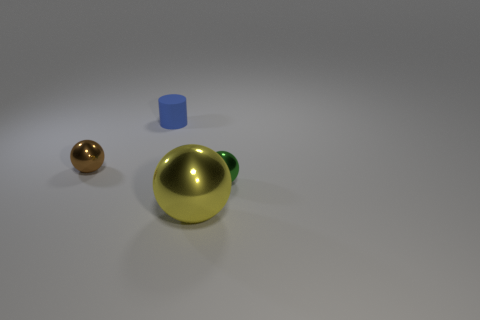Is there anything else that is the same material as the tiny blue cylinder?
Your answer should be very brief. No. What number of other objects are there of the same size as the blue cylinder?
Provide a succinct answer. 2. Does the tiny shiny thing in front of the brown thing have the same shape as the yellow thing?
Ensure brevity in your answer.  Yes. What number of small things are right of the brown shiny object and in front of the blue rubber cylinder?
Your answer should be very brief. 1. What is the blue cylinder made of?
Keep it short and to the point. Rubber. Does the big yellow thing have the same material as the tiny green object?
Provide a short and direct response. Yes. There is a object in front of the tiny metal sphere that is on the right side of the big thing; what number of blue things are to the left of it?
Offer a very short reply. 1. What number of blue cylinders are there?
Offer a terse response. 1. Is the number of small green spheres in front of the green metal sphere less than the number of tiny green metallic balls right of the yellow metallic ball?
Give a very brief answer. Yes. Are there fewer large balls that are to the right of the tiny green object than small blue matte objects?
Provide a succinct answer. Yes. 